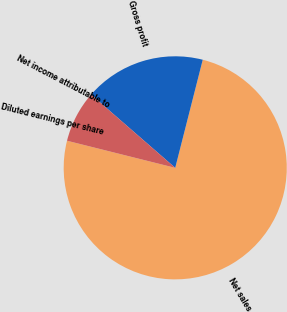<chart> <loc_0><loc_0><loc_500><loc_500><pie_chart><fcel>Net sales<fcel>Gross profit<fcel>Net income attributable to<fcel>Diluted earnings per share<nl><fcel>74.93%<fcel>17.57%<fcel>7.49%<fcel>0.0%<nl></chart> 